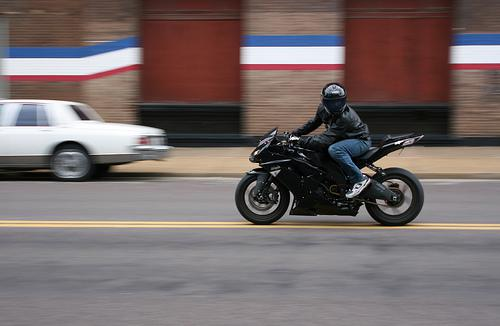Question: what is moving?
Choices:
A. Car.
B. Bicycle.
C. Motorcycle.
D. Fire truck.
Answer with the letter. Answer: C Question: what is blue?
Choices:
A. The sky.
B. Jeans.
C. Ocean.
D. Ink.
Answer with the letter. Answer: B Question: how many bikes?
Choices:
A. Two.
B. Four.
C. One.
D. Five.
Answer with the letter. Answer: C Question: why is the car stopped?
Choices:
A. Red light.
B. Police stop.
C. Parked.
D. Out of gas.
Answer with the letter. Answer: C Question: when was the picture taken?
Choices:
A. Christmas Day.
B. Daytime.
C. Night time.
D. After midnight.
Answer with the letter. Answer: B Question: who is riding?
Choices:
A. Woman.
B. Man.
C. Child.
D. Dog.
Answer with the letter. Answer: B 